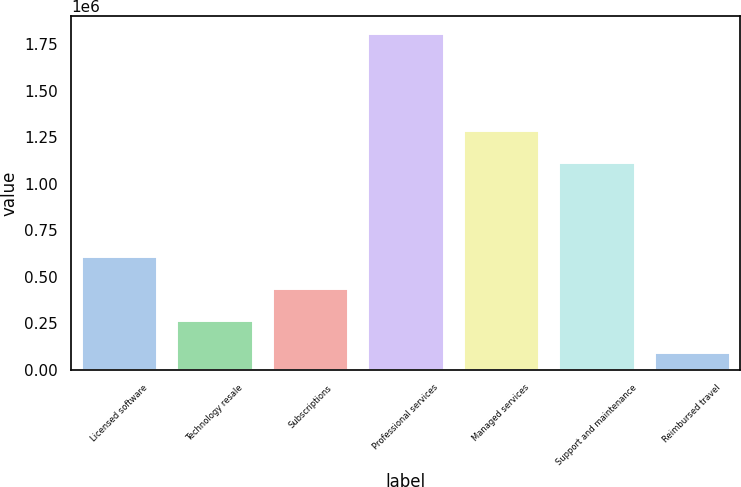<chart> <loc_0><loc_0><loc_500><loc_500><bar_chart><fcel>Licensed software<fcel>Technology resale<fcel>Subscriptions<fcel>Professional services<fcel>Managed services<fcel>Support and maintenance<fcel>Reimbursed travel<nl><fcel>613578<fcel>268844<fcel>440246<fcel>1.81146e+06<fcel>1.28952e+06<fcel>1.11812e+06<fcel>97442<nl></chart> 